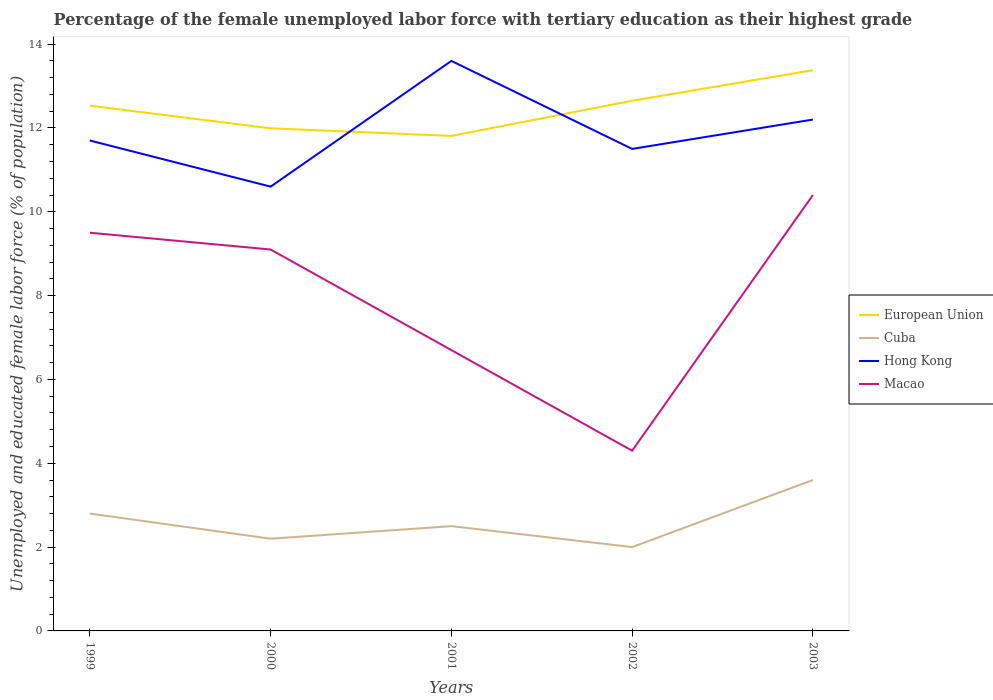Is the number of lines equal to the number of legend labels?
Give a very brief answer. Yes. Across all years, what is the maximum percentage of the unemployed female labor force with tertiary education in Hong Kong?
Offer a terse response. 10.6. In which year was the percentage of the unemployed female labor force with tertiary education in Macao maximum?
Provide a succinct answer. 2002. What is the total percentage of the unemployed female labor force with tertiary education in Cuba in the graph?
Make the answer very short. -1.1. What is the difference between the highest and the second highest percentage of the unemployed female labor force with tertiary education in European Union?
Provide a succinct answer. 1.57. What is the difference between the highest and the lowest percentage of the unemployed female labor force with tertiary education in Hong Kong?
Keep it short and to the point. 2. How many lines are there?
Your response must be concise. 4. How many years are there in the graph?
Give a very brief answer. 5. Are the values on the major ticks of Y-axis written in scientific E-notation?
Give a very brief answer. No. Does the graph contain grids?
Your response must be concise. No. Where does the legend appear in the graph?
Offer a terse response. Center right. How many legend labels are there?
Provide a short and direct response. 4. How are the legend labels stacked?
Ensure brevity in your answer.  Vertical. What is the title of the graph?
Your response must be concise. Percentage of the female unemployed labor force with tertiary education as their highest grade. What is the label or title of the X-axis?
Ensure brevity in your answer.  Years. What is the label or title of the Y-axis?
Provide a short and direct response. Unemployed and educated female labor force (% of population). What is the Unemployed and educated female labor force (% of population) of European Union in 1999?
Your answer should be compact. 12.53. What is the Unemployed and educated female labor force (% of population) in Cuba in 1999?
Ensure brevity in your answer.  2.8. What is the Unemployed and educated female labor force (% of population) of Hong Kong in 1999?
Provide a short and direct response. 11.7. What is the Unemployed and educated female labor force (% of population) in European Union in 2000?
Ensure brevity in your answer.  11.99. What is the Unemployed and educated female labor force (% of population) in Cuba in 2000?
Your response must be concise. 2.2. What is the Unemployed and educated female labor force (% of population) of Hong Kong in 2000?
Offer a terse response. 10.6. What is the Unemployed and educated female labor force (% of population) in Macao in 2000?
Make the answer very short. 9.1. What is the Unemployed and educated female labor force (% of population) in European Union in 2001?
Offer a terse response. 11.81. What is the Unemployed and educated female labor force (% of population) of Hong Kong in 2001?
Offer a terse response. 13.6. What is the Unemployed and educated female labor force (% of population) of Macao in 2001?
Your answer should be compact. 6.7. What is the Unemployed and educated female labor force (% of population) in European Union in 2002?
Your response must be concise. 12.65. What is the Unemployed and educated female labor force (% of population) in Cuba in 2002?
Ensure brevity in your answer.  2. What is the Unemployed and educated female labor force (% of population) of Hong Kong in 2002?
Provide a short and direct response. 11.5. What is the Unemployed and educated female labor force (% of population) of Macao in 2002?
Your answer should be compact. 4.3. What is the Unemployed and educated female labor force (% of population) in European Union in 2003?
Your answer should be very brief. 13.38. What is the Unemployed and educated female labor force (% of population) of Cuba in 2003?
Your response must be concise. 3.6. What is the Unemployed and educated female labor force (% of population) of Hong Kong in 2003?
Keep it short and to the point. 12.2. What is the Unemployed and educated female labor force (% of population) of Macao in 2003?
Your answer should be very brief. 10.4. Across all years, what is the maximum Unemployed and educated female labor force (% of population) in European Union?
Offer a very short reply. 13.38. Across all years, what is the maximum Unemployed and educated female labor force (% of population) in Cuba?
Keep it short and to the point. 3.6. Across all years, what is the maximum Unemployed and educated female labor force (% of population) of Hong Kong?
Make the answer very short. 13.6. Across all years, what is the maximum Unemployed and educated female labor force (% of population) in Macao?
Keep it short and to the point. 10.4. Across all years, what is the minimum Unemployed and educated female labor force (% of population) of European Union?
Offer a very short reply. 11.81. Across all years, what is the minimum Unemployed and educated female labor force (% of population) of Hong Kong?
Give a very brief answer. 10.6. Across all years, what is the minimum Unemployed and educated female labor force (% of population) in Macao?
Provide a succinct answer. 4.3. What is the total Unemployed and educated female labor force (% of population) of European Union in the graph?
Provide a short and direct response. 62.36. What is the total Unemployed and educated female labor force (% of population) in Hong Kong in the graph?
Offer a terse response. 59.6. What is the difference between the Unemployed and educated female labor force (% of population) of European Union in 1999 and that in 2000?
Your answer should be compact. 0.54. What is the difference between the Unemployed and educated female labor force (% of population) in Cuba in 1999 and that in 2000?
Your response must be concise. 0.6. What is the difference between the Unemployed and educated female labor force (% of population) in European Union in 1999 and that in 2001?
Your response must be concise. 0.72. What is the difference between the Unemployed and educated female labor force (% of population) in Macao in 1999 and that in 2001?
Your answer should be compact. 2.8. What is the difference between the Unemployed and educated female labor force (% of population) in European Union in 1999 and that in 2002?
Provide a short and direct response. -0.12. What is the difference between the Unemployed and educated female labor force (% of population) of Macao in 1999 and that in 2002?
Your answer should be very brief. 5.2. What is the difference between the Unemployed and educated female labor force (% of population) of European Union in 1999 and that in 2003?
Make the answer very short. -0.85. What is the difference between the Unemployed and educated female labor force (% of population) of Cuba in 1999 and that in 2003?
Provide a succinct answer. -0.8. What is the difference between the Unemployed and educated female labor force (% of population) of Macao in 1999 and that in 2003?
Your answer should be compact. -0.9. What is the difference between the Unemployed and educated female labor force (% of population) of European Union in 2000 and that in 2001?
Ensure brevity in your answer.  0.18. What is the difference between the Unemployed and educated female labor force (% of population) in European Union in 2000 and that in 2002?
Your response must be concise. -0.66. What is the difference between the Unemployed and educated female labor force (% of population) in Macao in 2000 and that in 2002?
Provide a short and direct response. 4.8. What is the difference between the Unemployed and educated female labor force (% of population) of European Union in 2000 and that in 2003?
Make the answer very short. -1.39. What is the difference between the Unemployed and educated female labor force (% of population) of Hong Kong in 2000 and that in 2003?
Your answer should be compact. -1.6. What is the difference between the Unemployed and educated female labor force (% of population) of Macao in 2000 and that in 2003?
Your response must be concise. -1.3. What is the difference between the Unemployed and educated female labor force (% of population) in European Union in 2001 and that in 2002?
Give a very brief answer. -0.84. What is the difference between the Unemployed and educated female labor force (% of population) in Macao in 2001 and that in 2002?
Your answer should be compact. 2.4. What is the difference between the Unemployed and educated female labor force (% of population) of European Union in 2001 and that in 2003?
Give a very brief answer. -1.57. What is the difference between the Unemployed and educated female labor force (% of population) in Cuba in 2001 and that in 2003?
Make the answer very short. -1.1. What is the difference between the Unemployed and educated female labor force (% of population) of Macao in 2001 and that in 2003?
Provide a short and direct response. -3.7. What is the difference between the Unemployed and educated female labor force (% of population) in European Union in 2002 and that in 2003?
Ensure brevity in your answer.  -0.73. What is the difference between the Unemployed and educated female labor force (% of population) in Cuba in 2002 and that in 2003?
Offer a very short reply. -1.6. What is the difference between the Unemployed and educated female labor force (% of population) of Macao in 2002 and that in 2003?
Ensure brevity in your answer.  -6.1. What is the difference between the Unemployed and educated female labor force (% of population) in European Union in 1999 and the Unemployed and educated female labor force (% of population) in Cuba in 2000?
Provide a short and direct response. 10.33. What is the difference between the Unemployed and educated female labor force (% of population) in European Union in 1999 and the Unemployed and educated female labor force (% of population) in Hong Kong in 2000?
Provide a succinct answer. 1.93. What is the difference between the Unemployed and educated female labor force (% of population) of European Union in 1999 and the Unemployed and educated female labor force (% of population) of Macao in 2000?
Your answer should be compact. 3.43. What is the difference between the Unemployed and educated female labor force (% of population) in Cuba in 1999 and the Unemployed and educated female labor force (% of population) in Macao in 2000?
Make the answer very short. -6.3. What is the difference between the Unemployed and educated female labor force (% of population) of European Union in 1999 and the Unemployed and educated female labor force (% of population) of Cuba in 2001?
Offer a terse response. 10.03. What is the difference between the Unemployed and educated female labor force (% of population) in European Union in 1999 and the Unemployed and educated female labor force (% of population) in Hong Kong in 2001?
Your answer should be very brief. -1.07. What is the difference between the Unemployed and educated female labor force (% of population) in European Union in 1999 and the Unemployed and educated female labor force (% of population) in Macao in 2001?
Your answer should be compact. 5.83. What is the difference between the Unemployed and educated female labor force (% of population) of Cuba in 1999 and the Unemployed and educated female labor force (% of population) of Hong Kong in 2001?
Give a very brief answer. -10.8. What is the difference between the Unemployed and educated female labor force (% of population) in European Union in 1999 and the Unemployed and educated female labor force (% of population) in Cuba in 2002?
Your answer should be compact. 10.53. What is the difference between the Unemployed and educated female labor force (% of population) in European Union in 1999 and the Unemployed and educated female labor force (% of population) in Hong Kong in 2002?
Keep it short and to the point. 1.03. What is the difference between the Unemployed and educated female labor force (% of population) of European Union in 1999 and the Unemployed and educated female labor force (% of population) of Macao in 2002?
Provide a succinct answer. 8.23. What is the difference between the Unemployed and educated female labor force (% of population) in Hong Kong in 1999 and the Unemployed and educated female labor force (% of population) in Macao in 2002?
Your response must be concise. 7.4. What is the difference between the Unemployed and educated female labor force (% of population) of European Union in 1999 and the Unemployed and educated female labor force (% of population) of Cuba in 2003?
Ensure brevity in your answer.  8.93. What is the difference between the Unemployed and educated female labor force (% of population) of European Union in 1999 and the Unemployed and educated female labor force (% of population) of Hong Kong in 2003?
Ensure brevity in your answer.  0.33. What is the difference between the Unemployed and educated female labor force (% of population) in European Union in 1999 and the Unemployed and educated female labor force (% of population) in Macao in 2003?
Your answer should be compact. 2.13. What is the difference between the Unemployed and educated female labor force (% of population) of Cuba in 1999 and the Unemployed and educated female labor force (% of population) of Hong Kong in 2003?
Your response must be concise. -9.4. What is the difference between the Unemployed and educated female labor force (% of population) in Cuba in 1999 and the Unemployed and educated female labor force (% of population) in Macao in 2003?
Offer a terse response. -7.6. What is the difference between the Unemployed and educated female labor force (% of population) in European Union in 2000 and the Unemployed and educated female labor force (% of population) in Cuba in 2001?
Make the answer very short. 9.49. What is the difference between the Unemployed and educated female labor force (% of population) of European Union in 2000 and the Unemployed and educated female labor force (% of population) of Hong Kong in 2001?
Keep it short and to the point. -1.61. What is the difference between the Unemployed and educated female labor force (% of population) in European Union in 2000 and the Unemployed and educated female labor force (% of population) in Macao in 2001?
Your answer should be very brief. 5.29. What is the difference between the Unemployed and educated female labor force (% of population) of European Union in 2000 and the Unemployed and educated female labor force (% of population) of Cuba in 2002?
Offer a terse response. 9.99. What is the difference between the Unemployed and educated female labor force (% of population) in European Union in 2000 and the Unemployed and educated female labor force (% of population) in Hong Kong in 2002?
Keep it short and to the point. 0.49. What is the difference between the Unemployed and educated female labor force (% of population) of European Union in 2000 and the Unemployed and educated female labor force (% of population) of Macao in 2002?
Your answer should be compact. 7.69. What is the difference between the Unemployed and educated female labor force (% of population) of Cuba in 2000 and the Unemployed and educated female labor force (% of population) of Macao in 2002?
Provide a short and direct response. -2.1. What is the difference between the Unemployed and educated female labor force (% of population) of Hong Kong in 2000 and the Unemployed and educated female labor force (% of population) of Macao in 2002?
Ensure brevity in your answer.  6.3. What is the difference between the Unemployed and educated female labor force (% of population) of European Union in 2000 and the Unemployed and educated female labor force (% of population) of Cuba in 2003?
Provide a short and direct response. 8.39. What is the difference between the Unemployed and educated female labor force (% of population) in European Union in 2000 and the Unemployed and educated female labor force (% of population) in Hong Kong in 2003?
Offer a very short reply. -0.21. What is the difference between the Unemployed and educated female labor force (% of population) in European Union in 2000 and the Unemployed and educated female labor force (% of population) in Macao in 2003?
Provide a short and direct response. 1.59. What is the difference between the Unemployed and educated female labor force (% of population) of Cuba in 2000 and the Unemployed and educated female labor force (% of population) of Hong Kong in 2003?
Provide a short and direct response. -10. What is the difference between the Unemployed and educated female labor force (% of population) in Hong Kong in 2000 and the Unemployed and educated female labor force (% of population) in Macao in 2003?
Offer a terse response. 0.2. What is the difference between the Unemployed and educated female labor force (% of population) in European Union in 2001 and the Unemployed and educated female labor force (% of population) in Cuba in 2002?
Keep it short and to the point. 9.81. What is the difference between the Unemployed and educated female labor force (% of population) of European Union in 2001 and the Unemployed and educated female labor force (% of population) of Hong Kong in 2002?
Offer a terse response. 0.31. What is the difference between the Unemployed and educated female labor force (% of population) of European Union in 2001 and the Unemployed and educated female labor force (% of population) of Macao in 2002?
Provide a succinct answer. 7.51. What is the difference between the Unemployed and educated female labor force (% of population) of Cuba in 2001 and the Unemployed and educated female labor force (% of population) of Macao in 2002?
Provide a succinct answer. -1.8. What is the difference between the Unemployed and educated female labor force (% of population) of Hong Kong in 2001 and the Unemployed and educated female labor force (% of population) of Macao in 2002?
Keep it short and to the point. 9.3. What is the difference between the Unemployed and educated female labor force (% of population) in European Union in 2001 and the Unemployed and educated female labor force (% of population) in Cuba in 2003?
Your answer should be very brief. 8.21. What is the difference between the Unemployed and educated female labor force (% of population) of European Union in 2001 and the Unemployed and educated female labor force (% of population) of Hong Kong in 2003?
Your answer should be compact. -0.39. What is the difference between the Unemployed and educated female labor force (% of population) in European Union in 2001 and the Unemployed and educated female labor force (% of population) in Macao in 2003?
Your answer should be compact. 1.41. What is the difference between the Unemployed and educated female labor force (% of population) in Cuba in 2001 and the Unemployed and educated female labor force (% of population) in Macao in 2003?
Your answer should be compact. -7.9. What is the difference between the Unemployed and educated female labor force (% of population) in Hong Kong in 2001 and the Unemployed and educated female labor force (% of population) in Macao in 2003?
Give a very brief answer. 3.2. What is the difference between the Unemployed and educated female labor force (% of population) of European Union in 2002 and the Unemployed and educated female labor force (% of population) of Cuba in 2003?
Give a very brief answer. 9.05. What is the difference between the Unemployed and educated female labor force (% of population) of European Union in 2002 and the Unemployed and educated female labor force (% of population) of Hong Kong in 2003?
Offer a terse response. 0.45. What is the difference between the Unemployed and educated female labor force (% of population) in European Union in 2002 and the Unemployed and educated female labor force (% of population) in Macao in 2003?
Your answer should be compact. 2.25. What is the average Unemployed and educated female labor force (% of population) of European Union per year?
Make the answer very short. 12.47. What is the average Unemployed and educated female labor force (% of population) of Cuba per year?
Provide a succinct answer. 2.62. What is the average Unemployed and educated female labor force (% of population) of Hong Kong per year?
Your answer should be compact. 11.92. What is the average Unemployed and educated female labor force (% of population) in Macao per year?
Offer a terse response. 8. In the year 1999, what is the difference between the Unemployed and educated female labor force (% of population) in European Union and Unemployed and educated female labor force (% of population) in Cuba?
Your answer should be very brief. 9.73. In the year 1999, what is the difference between the Unemployed and educated female labor force (% of population) of European Union and Unemployed and educated female labor force (% of population) of Hong Kong?
Provide a short and direct response. 0.83. In the year 1999, what is the difference between the Unemployed and educated female labor force (% of population) of European Union and Unemployed and educated female labor force (% of population) of Macao?
Ensure brevity in your answer.  3.03. In the year 1999, what is the difference between the Unemployed and educated female labor force (% of population) of Cuba and Unemployed and educated female labor force (% of population) of Hong Kong?
Your answer should be very brief. -8.9. In the year 1999, what is the difference between the Unemployed and educated female labor force (% of population) of Cuba and Unemployed and educated female labor force (% of population) of Macao?
Your answer should be very brief. -6.7. In the year 1999, what is the difference between the Unemployed and educated female labor force (% of population) of Hong Kong and Unemployed and educated female labor force (% of population) of Macao?
Your answer should be compact. 2.2. In the year 2000, what is the difference between the Unemployed and educated female labor force (% of population) of European Union and Unemployed and educated female labor force (% of population) of Cuba?
Your response must be concise. 9.79. In the year 2000, what is the difference between the Unemployed and educated female labor force (% of population) in European Union and Unemployed and educated female labor force (% of population) in Hong Kong?
Provide a short and direct response. 1.39. In the year 2000, what is the difference between the Unemployed and educated female labor force (% of population) in European Union and Unemployed and educated female labor force (% of population) in Macao?
Provide a succinct answer. 2.89. In the year 2000, what is the difference between the Unemployed and educated female labor force (% of population) of Cuba and Unemployed and educated female labor force (% of population) of Macao?
Offer a terse response. -6.9. In the year 2000, what is the difference between the Unemployed and educated female labor force (% of population) of Hong Kong and Unemployed and educated female labor force (% of population) of Macao?
Your response must be concise. 1.5. In the year 2001, what is the difference between the Unemployed and educated female labor force (% of population) in European Union and Unemployed and educated female labor force (% of population) in Cuba?
Your response must be concise. 9.31. In the year 2001, what is the difference between the Unemployed and educated female labor force (% of population) of European Union and Unemployed and educated female labor force (% of population) of Hong Kong?
Your answer should be very brief. -1.79. In the year 2001, what is the difference between the Unemployed and educated female labor force (% of population) of European Union and Unemployed and educated female labor force (% of population) of Macao?
Make the answer very short. 5.11. In the year 2001, what is the difference between the Unemployed and educated female labor force (% of population) of Cuba and Unemployed and educated female labor force (% of population) of Macao?
Keep it short and to the point. -4.2. In the year 2001, what is the difference between the Unemployed and educated female labor force (% of population) in Hong Kong and Unemployed and educated female labor force (% of population) in Macao?
Provide a succinct answer. 6.9. In the year 2002, what is the difference between the Unemployed and educated female labor force (% of population) in European Union and Unemployed and educated female labor force (% of population) in Cuba?
Give a very brief answer. 10.65. In the year 2002, what is the difference between the Unemployed and educated female labor force (% of population) of European Union and Unemployed and educated female labor force (% of population) of Hong Kong?
Your response must be concise. 1.15. In the year 2002, what is the difference between the Unemployed and educated female labor force (% of population) of European Union and Unemployed and educated female labor force (% of population) of Macao?
Ensure brevity in your answer.  8.35. In the year 2002, what is the difference between the Unemployed and educated female labor force (% of population) in Cuba and Unemployed and educated female labor force (% of population) in Hong Kong?
Your answer should be compact. -9.5. In the year 2002, what is the difference between the Unemployed and educated female labor force (% of population) of Cuba and Unemployed and educated female labor force (% of population) of Macao?
Ensure brevity in your answer.  -2.3. In the year 2002, what is the difference between the Unemployed and educated female labor force (% of population) in Hong Kong and Unemployed and educated female labor force (% of population) in Macao?
Provide a succinct answer. 7.2. In the year 2003, what is the difference between the Unemployed and educated female labor force (% of population) in European Union and Unemployed and educated female labor force (% of population) in Cuba?
Your answer should be very brief. 9.78. In the year 2003, what is the difference between the Unemployed and educated female labor force (% of population) in European Union and Unemployed and educated female labor force (% of population) in Hong Kong?
Make the answer very short. 1.18. In the year 2003, what is the difference between the Unemployed and educated female labor force (% of population) of European Union and Unemployed and educated female labor force (% of population) of Macao?
Make the answer very short. 2.98. In the year 2003, what is the difference between the Unemployed and educated female labor force (% of population) of Cuba and Unemployed and educated female labor force (% of population) of Hong Kong?
Your answer should be very brief. -8.6. In the year 2003, what is the difference between the Unemployed and educated female labor force (% of population) of Hong Kong and Unemployed and educated female labor force (% of population) of Macao?
Your answer should be compact. 1.8. What is the ratio of the Unemployed and educated female labor force (% of population) of European Union in 1999 to that in 2000?
Provide a succinct answer. 1.05. What is the ratio of the Unemployed and educated female labor force (% of population) of Cuba in 1999 to that in 2000?
Your response must be concise. 1.27. What is the ratio of the Unemployed and educated female labor force (% of population) in Hong Kong in 1999 to that in 2000?
Offer a very short reply. 1.1. What is the ratio of the Unemployed and educated female labor force (% of population) of Macao in 1999 to that in 2000?
Give a very brief answer. 1.04. What is the ratio of the Unemployed and educated female labor force (% of population) of European Union in 1999 to that in 2001?
Keep it short and to the point. 1.06. What is the ratio of the Unemployed and educated female labor force (% of population) in Cuba in 1999 to that in 2001?
Provide a short and direct response. 1.12. What is the ratio of the Unemployed and educated female labor force (% of population) of Hong Kong in 1999 to that in 2001?
Make the answer very short. 0.86. What is the ratio of the Unemployed and educated female labor force (% of population) of Macao in 1999 to that in 2001?
Make the answer very short. 1.42. What is the ratio of the Unemployed and educated female labor force (% of population) of European Union in 1999 to that in 2002?
Offer a very short reply. 0.99. What is the ratio of the Unemployed and educated female labor force (% of population) in Cuba in 1999 to that in 2002?
Your answer should be compact. 1.4. What is the ratio of the Unemployed and educated female labor force (% of population) in Hong Kong in 1999 to that in 2002?
Your response must be concise. 1.02. What is the ratio of the Unemployed and educated female labor force (% of population) of Macao in 1999 to that in 2002?
Your answer should be compact. 2.21. What is the ratio of the Unemployed and educated female labor force (% of population) of European Union in 1999 to that in 2003?
Offer a very short reply. 0.94. What is the ratio of the Unemployed and educated female labor force (% of population) of Hong Kong in 1999 to that in 2003?
Your answer should be compact. 0.96. What is the ratio of the Unemployed and educated female labor force (% of population) in Macao in 1999 to that in 2003?
Ensure brevity in your answer.  0.91. What is the ratio of the Unemployed and educated female labor force (% of population) in European Union in 2000 to that in 2001?
Offer a very short reply. 1.02. What is the ratio of the Unemployed and educated female labor force (% of population) of Hong Kong in 2000 to that in 2001?
Provide a short and direct response. 0.78. What is the ratio of the Unemployed and educated female labor force (% of population) in Macao in 2000 to that in 2001?
Your response must be concise. 1.36. What is the ratio of the Unemployed and educated female labor force (% of population) of European Union in 2000 to that in 2002?
Your response must be concise. 0.95. What is the ratio of the Unemployed and educated female labor force (% of population) of Hong Kong in 2000 to that in 2002?
Offer a very short reply. 0.92. What is the ratio of the Unemployed and educated female labor force (% of population) of Macao in 2000 to that in 2002?
Make the answer very short. 2.12. What is the ratio of the Unemployed and educated female labor force (% of population) of European Union in 2000 to that in 2003?
Provide a short and direct response. 0.9. What is the ratio of the Unemployed and educated female labor force (% of population) of Cuba in 2000 to that in 2003?
Give a very brief answer. 0.61. What is the ratio of the Unemployed and educated female labor force (% of population) in Hong Kong in 2000 to that in 2003?
Offer a very short reply. 0.87. What is the ratio of the Unemployed and educated female labor force (% of population) in European Union in 2001 to that in 2002?
Your answer should be compact. 0.93. What is the ratio of the Unemployed and educated female labor force (% of population) in Hong Kong in 2001 to that in 2002?
Keep it short and to the point. 1.18. What is the ratio of the Unemployed and educated female labor force (% of population) in Macao in 2001 to that in 2002?
Offer a very short reply. 1.56. What is the ratio of the Unemployed and educated female labor force (% of population) of European Union in 2001 to that in 2003?
Give a very brief answer. 0.88. What is the ratio of the Unemployed and educated female labor force (% of population) in Cuba in 2001 to that in 2003?
Make the answer very short. 0.69. What is the ratio of the Unemployed and educated female labor force (% of population) in Hong Kong in 2001 to that in 2003?
Offer a very short reply. 1.11. What is the ratio of the Unemployed and educated female labor force (% of population) of Macao in 2001 to that in 2003?
Your answer should be compact. 0.64. What is the ratio of the Unemployed and educated female labor force (% of population) of European Union in 2002 to that in 2003?
Your answer should be compact. 0.95. What is the ratio of the Unemployed and educated female labor force (% of population) of Cuba in 2002 to that in 2003?
Keep it short and to the point. 0.56. What is the ratio of the Unemployed and educated female labor force (% of population) of Hong Kong in 2002 to that in 2003?
Your answer should be very brief. 0.94. What is the ratio of the Unemployed and educated female labor force (% of population) of Macao in 2002 to that in 2003?
Make the answer very short. 0.41. What is the difference between the highest and the second highest Unemployed and educated female labor force (% of population) in European Union?
Make the answer very short. 0.73. What is the difference between the highest and the second highest Unemployed and educated female labor force (% of population) of Cuba?
Provide a short and direct response. 0.8. What is the difference between the highest and the second highest Unemployed and educated female labor force (% of population) of Macao?
Provide a succinct answer. 0.9. What is the difference between the highest and the lowest Unemployed and educated female labor force (% of population) in European Union?
Offer a very short reply. 1.57. What is the difference between the highest and the lowest Unemployed and educated female labor force (% of population) in Hong Kong?
Offer a very short reply. 3. 